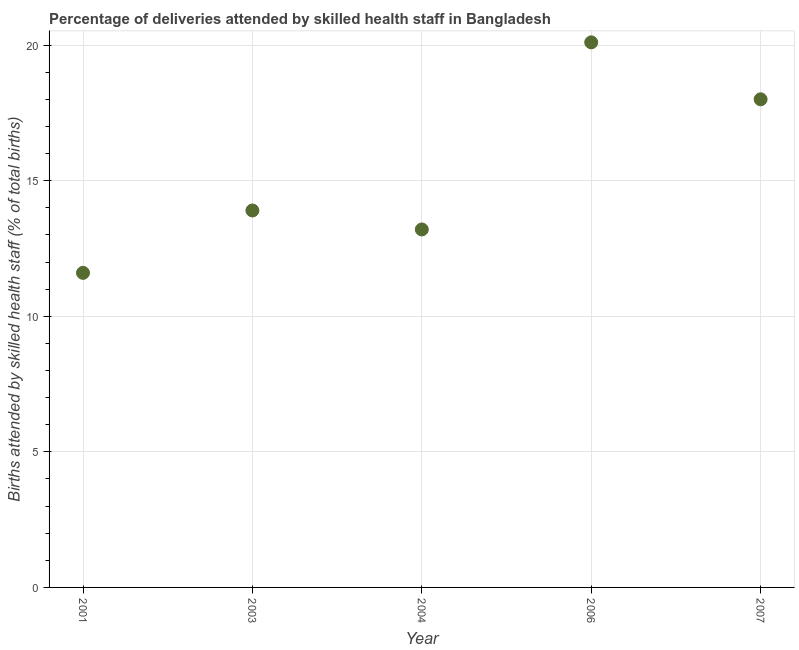Across all years, what is the maximum number of births attended by skilled health staff?
Your answer should be very brief. 20.1. In which year was the number of births attended by skilled health staff maximum?
Make the answer very short. 2006. What is the sum of the number of births attended by skilled health staff?
Provide a succinct answer. 76.8. What is the difference between the number of births attended by skilled health staff in 2004 and 2007?
Make the answer very short. -4.8. What is the average number of births attended by skilled health staff per year?
Provide a succinct answer. 15.36. In how many years, is the number of births attended by skilled health staff greater than 5 %?
Your answer should be very brief. 5. Do a majority of the years between 2001 and 2004 (inclusive) have number of births attended by skilled health staff greater than 19 %?
Provide a short and direct response. No. What is the ratio of the number of births attended by skilled health staff in 2004 to that in 2007?
Your answer should be very brief. 0.73. Is the number of births attended by skilled health staff in 2001 less than that in 2007?
Give a very brief answer. Yes. Is the difference between the number of births attended by skilled health staff in 2003 and 2004 greater than the difference between any two years?
Offer a terse response. No. What is the difference between the highest and the second highest number of births attended by skilled health staff?
Your response must be concise. 2.1. Is the sum of the number of births attended by skilled health staff in 2004 and 2007 greater than the maximum number of births attended by skilled health staff across all years?
Provide a succinct answer. Yes. What is the difference between the highest and the lowest number of births attended by skilled health staff?
Provide a succinct answer. 8.5. Does the number of births attended by skilled health staff monotonically increase over the years?
Your answer should be compact. No. How many years are there in the graph?
Give a very brief answer. 5. What is the difference between two consecutive major ticks on the Y-axis?
Provide a succinct answer. 5. What is the title of the graph?
Give a very brief answer. Percentage of deliveries attended by skilled health staff in Bangladesh. What is the label or title of the X-axis?
Your answer should be very brief. Year. What is the label or title of the Y-axis?
Give a very brief answer. Births attended by skilled health staff (% of total births). What is the Births attended by skilled health staff (% of total births) in 2001?
Your answer should be very brief. 11.6. What is the Births attended by skilled health staff (% of total births) in 2006?
Offer a very short reply. 20.1. What is the difference between the Births attended by skilled health staff (% of total births) in 2001 and 2006?
Ensure brevity in your answer.  -8.5. What is the difference between the Births attended by skilled health staff (% of total births) in 2001 and 2007?
Give a very brief answer. -6.4. What is the difference between the Births attended by skilled health staff (% of total births) in 2003 and 2006?
Your response must be concise. -6.2. What is the difference between the Births attended by skilled health staff (% of total births) in 2003 and 2007?
Offer a very short reply. -4.1. What is the difference between the Births attended by skilled health staff (% of total births) in 2004 and 2006?
Provide a succinct answer. -6.9. What is the difference between the Births attended by skilled health staff (% of total births) in 2004 and 2007?
Provide a short and direct response. -4.8. What is the ratio of the Births attended by skilled health staff (% of total births) in 2001 to that in 2003?
Offer a very short reply. 0.83. What is the ratio of the Births attended by skilled health staff (% of total births) in 2001 to that in 2004?
Your answer should be compact. 0.88. What is the ratio of the Births attended by skilled health staff (% of total births) in 2001 to that in 2006?
Keep it short and to the point. 0.58. What is the ratio of the Births attended by skilled health staff (% of total births) in 2001 to that in 2007?
Your answer should be very brief. 0.64. What is the ratio of the Births attended by skilled health staff (% of total births) in 2003 to that in 2004?
Your answer should be compact. 1.05. What is the ratio of the Births attended by skilled health staff (% of total births) in 2003 to that in 2006?
Your response must be concise. 0.69. What is the ratio of the Births attended by skilled health staff (% of total births) in 2003 to that in 2007?
Your answer should be compact. 0.77. What is the ratio of the Births attended by skilled health staff (% of total births) in 2004 to that in 2006?
Keep it short and to the point. 0.66. What is the ratio of the Births attended by skilled health staff (% of total births) in 2004 to that in 2007?
Provide a succinct answer. 0.73. What is the ratio of the Births attended by skilled health staff (% of total births) in 2006 to that in 2007?
Your response must be concise. 1.12. 